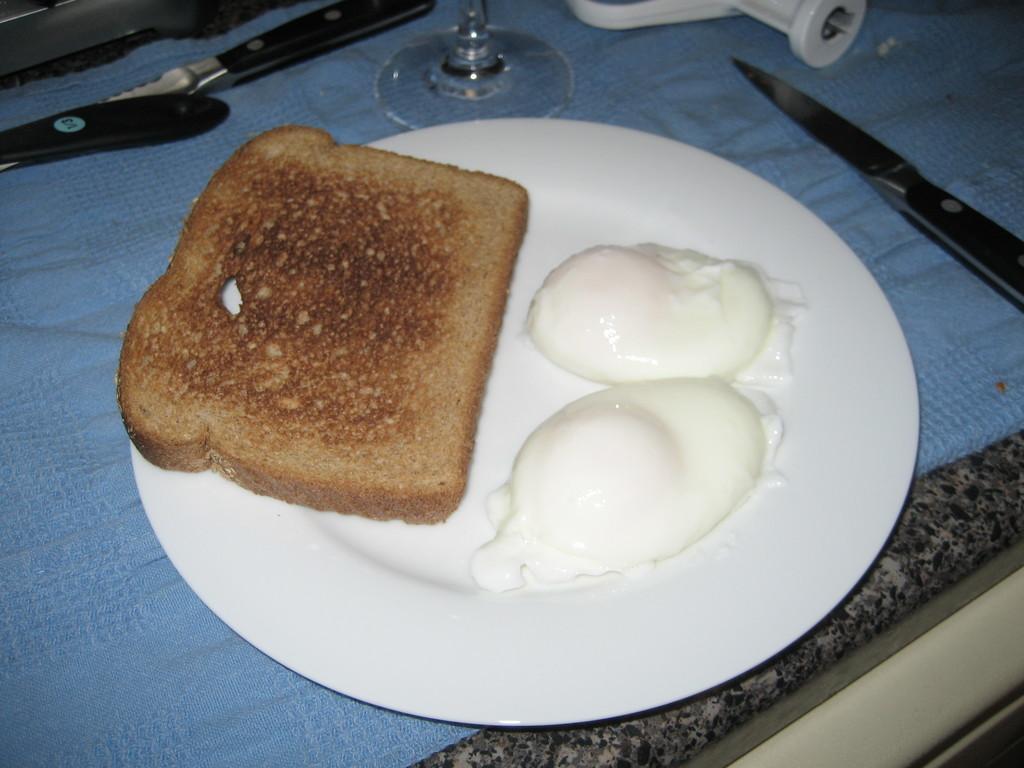How would you summarize this image in a sentence or two? In this picture there is a table. On the table i can see the knife, white plate, bread, cream, wine glass and cloth. In the top left corner there is a window. 